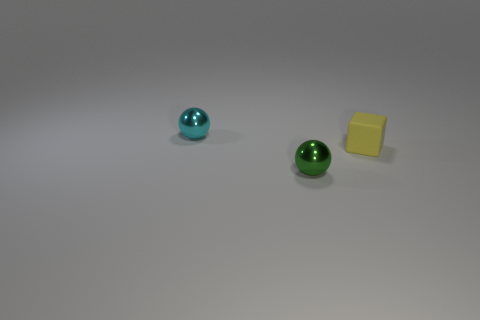What number of other objects are there of the same shape as the yellow thing?
Offer a terse response. 0. What number of green objects are metal objects or small objects?
Offer a terse response. 1. Are there any yellow matte cubes of the same size as the green shiny ball?
Offer a very short reply. Yes. There is a small ball that is left of the shiny ball that is to the right of the cyan thing that is behind the tiny green metal ball; what is its material?
Offer a very short reply. Metal. Are there an equal number of tiny yellow matte blocks that are on the left side of the tiny matte block and tiny cyan rubber objects?
Provide a short and direct response. Yes. Is the ball in front of the cyan object made of the same material as the small object that is behind the tiny yellow cube?
Provide a succinct answer. Yes. How many objects are either yellow rubber cubes or small rubber blocks that are in front of the cyan shiny sphere?
Offer a very short reply. 1. Is there a green thing that has the same shape as the tiny cyan shiny object?
Offer a very short reply. Yes. What size is the metallic thing that is to the right of the metallic thing left of the tiny shiny ball that is in front of the yellow matte cube?
Keep it short and to the point. Small. Are there the same number of tiny yellow matte blocks that are behind the small yellow rubber block and small shiny balls that are right of the green shiny ball?
Make the answer very short. Yes. 